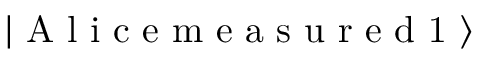Convert formula to latex. <formula><loc_0><loc_0><loc_500><loc_500>\left | A l i c e m e a s u r e d 1 \right \rangle</formula> 